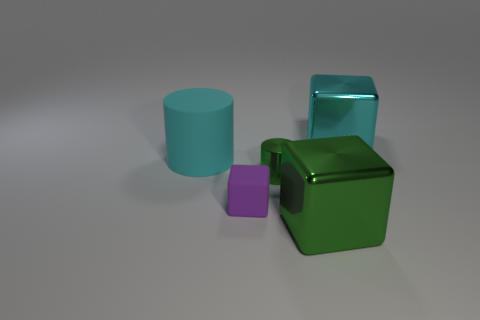Subtract all big cubes. How many cubes are left? 1 Add 1 big cyan shiny cubes. How many objects exist? 6 Subtract all green blocks. How many blocks are left? 2 Subtract all cylinders. How many objects are left? 3 Subtract 0 brown balls. How many objects are left? 5 Subtract 1 cubes. How many cubes are left? 2 Subtract all blue cylinders. Subtract all cyan balls. How many cylinders are left? 2 Subtract all purple cubes. How many cyan cylinders are left? 1 Subtract all tiny brown spheres. Subtract all purple matte things. How many objects are left? 4 Add 1 big cyan shiny cubes. How many big cyan shiny cubes are left? 2 